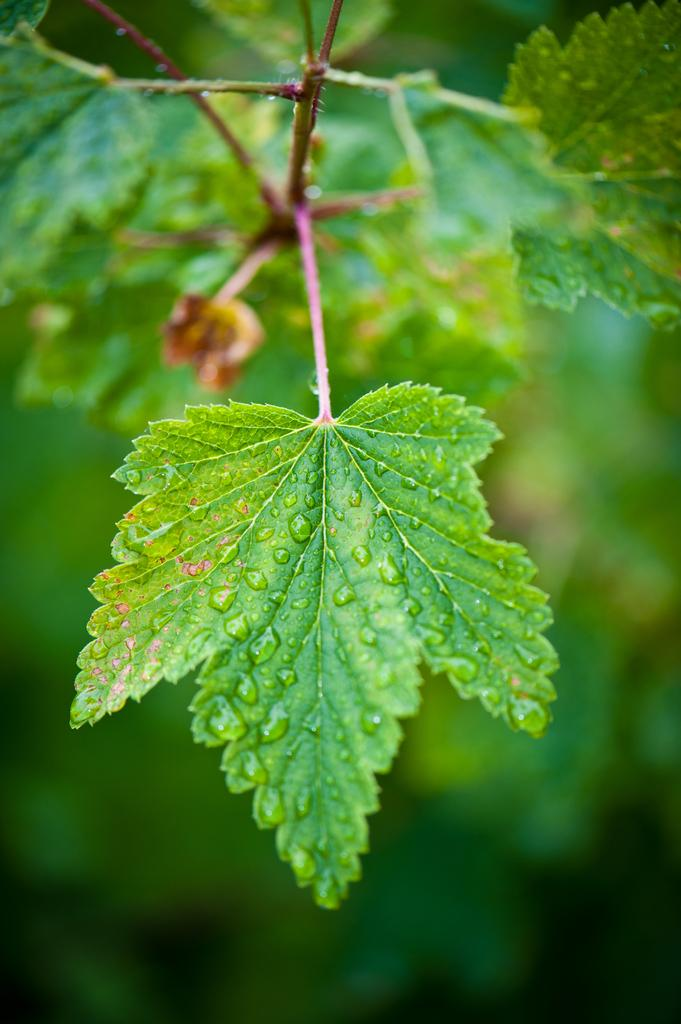What type of vegetation is present in the image? There are green leaves in the image. Can you describe the condition of the leaves? There are water drops on the leaves. Who is the actor that can be seen giving birth in the image? There is no actor or birth scene present in the image; it features green leaves with water drops. 